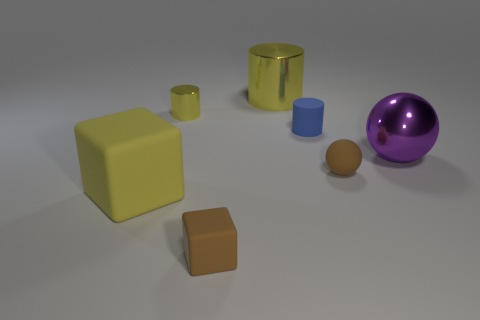What is the size of the other metallic object that is the same shape as the tiny yellow shiny thing?
Your answer should be compact. Large. What material is the purple ball?
Offer a terse response. Metal. The rubber block that is the same color as the large metallic cylinder is what size?
Give a very brief answer. Large. Does the small matte ball have the same color as the rubber block that is right of the small metallic cylinder?
Keep it short and to the point. Yes. There is a large thing that is in front of the purple metal object; is its color the same as the big cylinder?
Keep it short and to the point. Yes. There is a rubber cylinder that is behind the thing that is in front of the big rubber object; how many cylinders are on the left side of it?
Give a very brief answer. 2. What number of small objects are both in front of the large metallic sphere and to the left of the brown sphere?
Provide a short and direct response. 1. There is a thing that is the same color as the small ball; what is its shape?
Provide a succinct answer. Cube. Is the small brown sphere made of the same material as the tiny yellow cylinder?
Offer a terse response. No. There is a rubber object left of the brown thing to the left of the brown sphere that is left of the purple object; what shape is it?
Provide a succinct answer. Cube. 